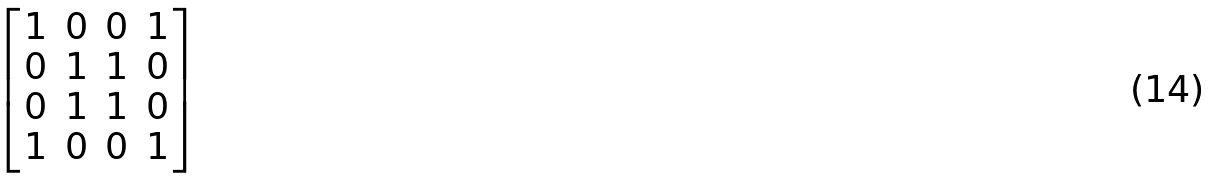Convert formula to latex. <formula><loc_0><loc_0><loc_500><loc_500>\begin{bmatrix} 1 & 0 & 0 & 1 \\ 0 & 1 & 1 & 0 \\ 0 & 1 & 1 & 0 \\ 1 & 0 & 0 & 1 \end{bmatrix}</formula> 